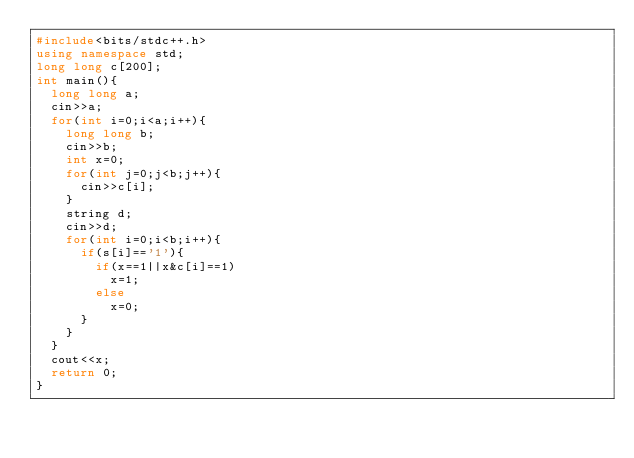Convert code to text. <code><loc_0><loc_0><loc_500><loc_500><_C++_>#include<bits/stdc++.h>
using namespace std;
long long c[200];
int main(){
  long long a;
  cin>>a;
  for(int i=0;i<a;i++){
    long long b;
    cin>>b;
    int x=0;
    for(int j=0;j<b;j++){
      cin>>c[i];
    }
    string d;
    cin>>d;
    for(int i=0;i<b;i++){
      if(s[i]=='1'){
        if(x==1||x&c[i]==1)
          x=1;
        else
          x=0;
      }
    }
  }
  cout<<x;
  return 0;
}</code> 